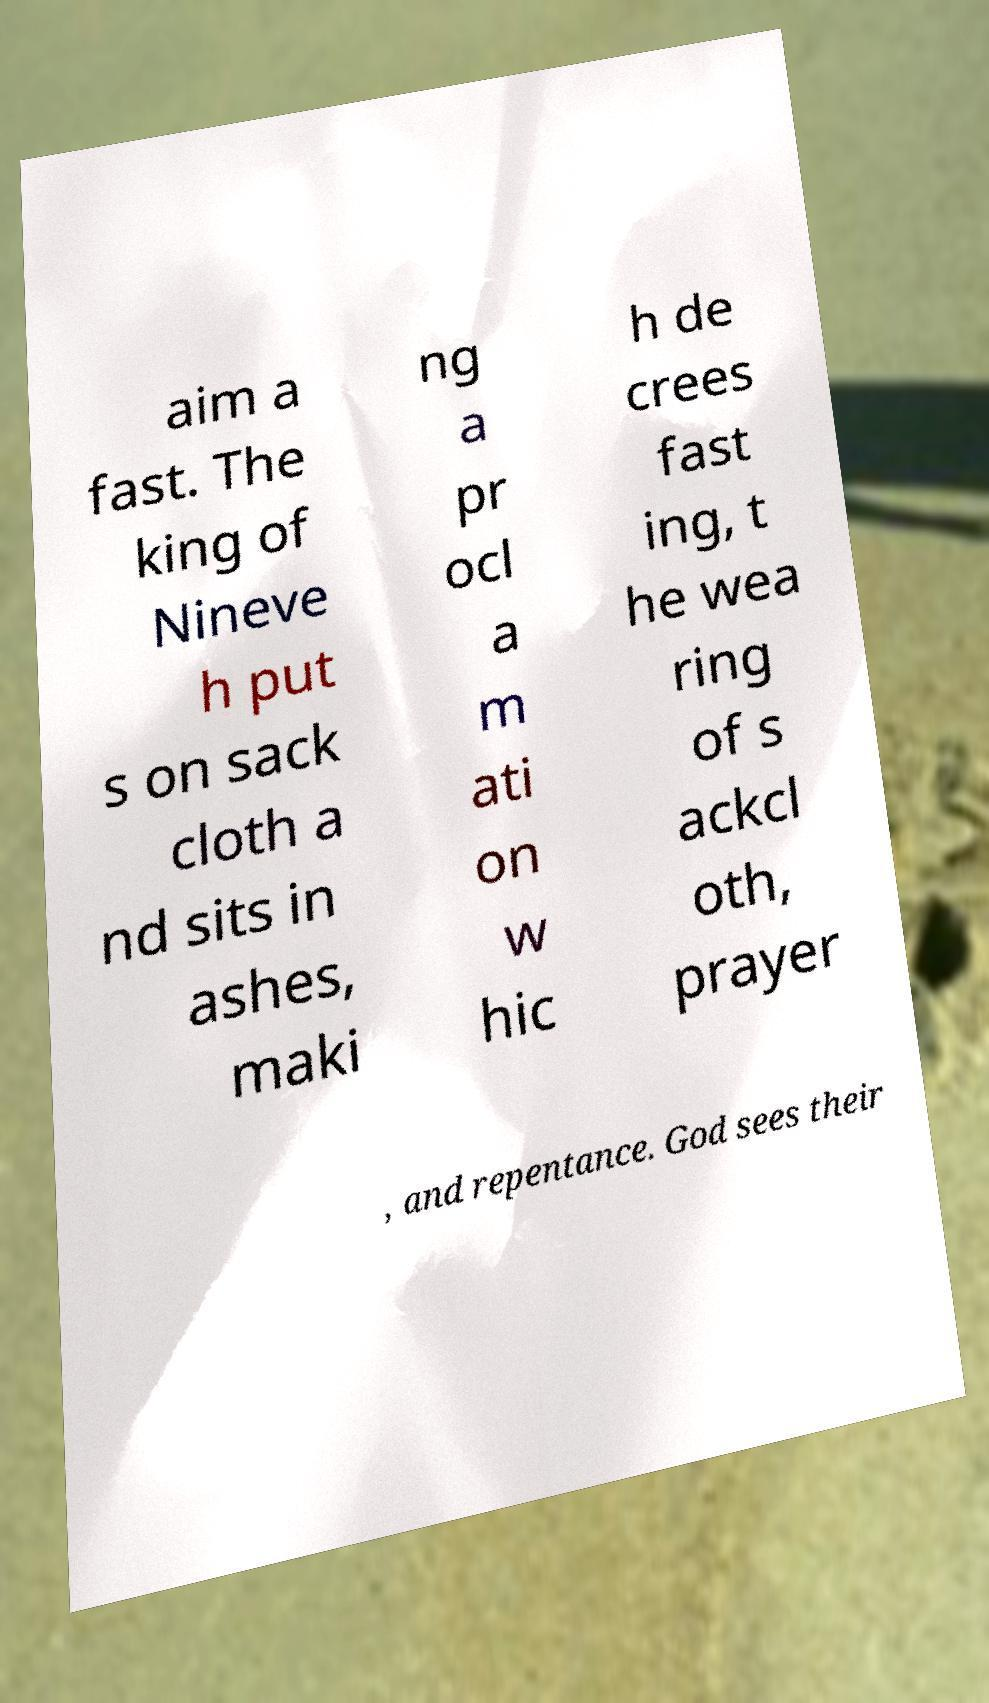There's text embedded in this image that I need extracted. Can you transcribe it verbatim? aim a fast. The king of Nineve h put s on sack cloth a nd sits in ashes, maki ng a pr ocl a m ati on w hic h de crees fast ing, t he wea ring of s ackcl oth, prayer , and repentance. God sees their 